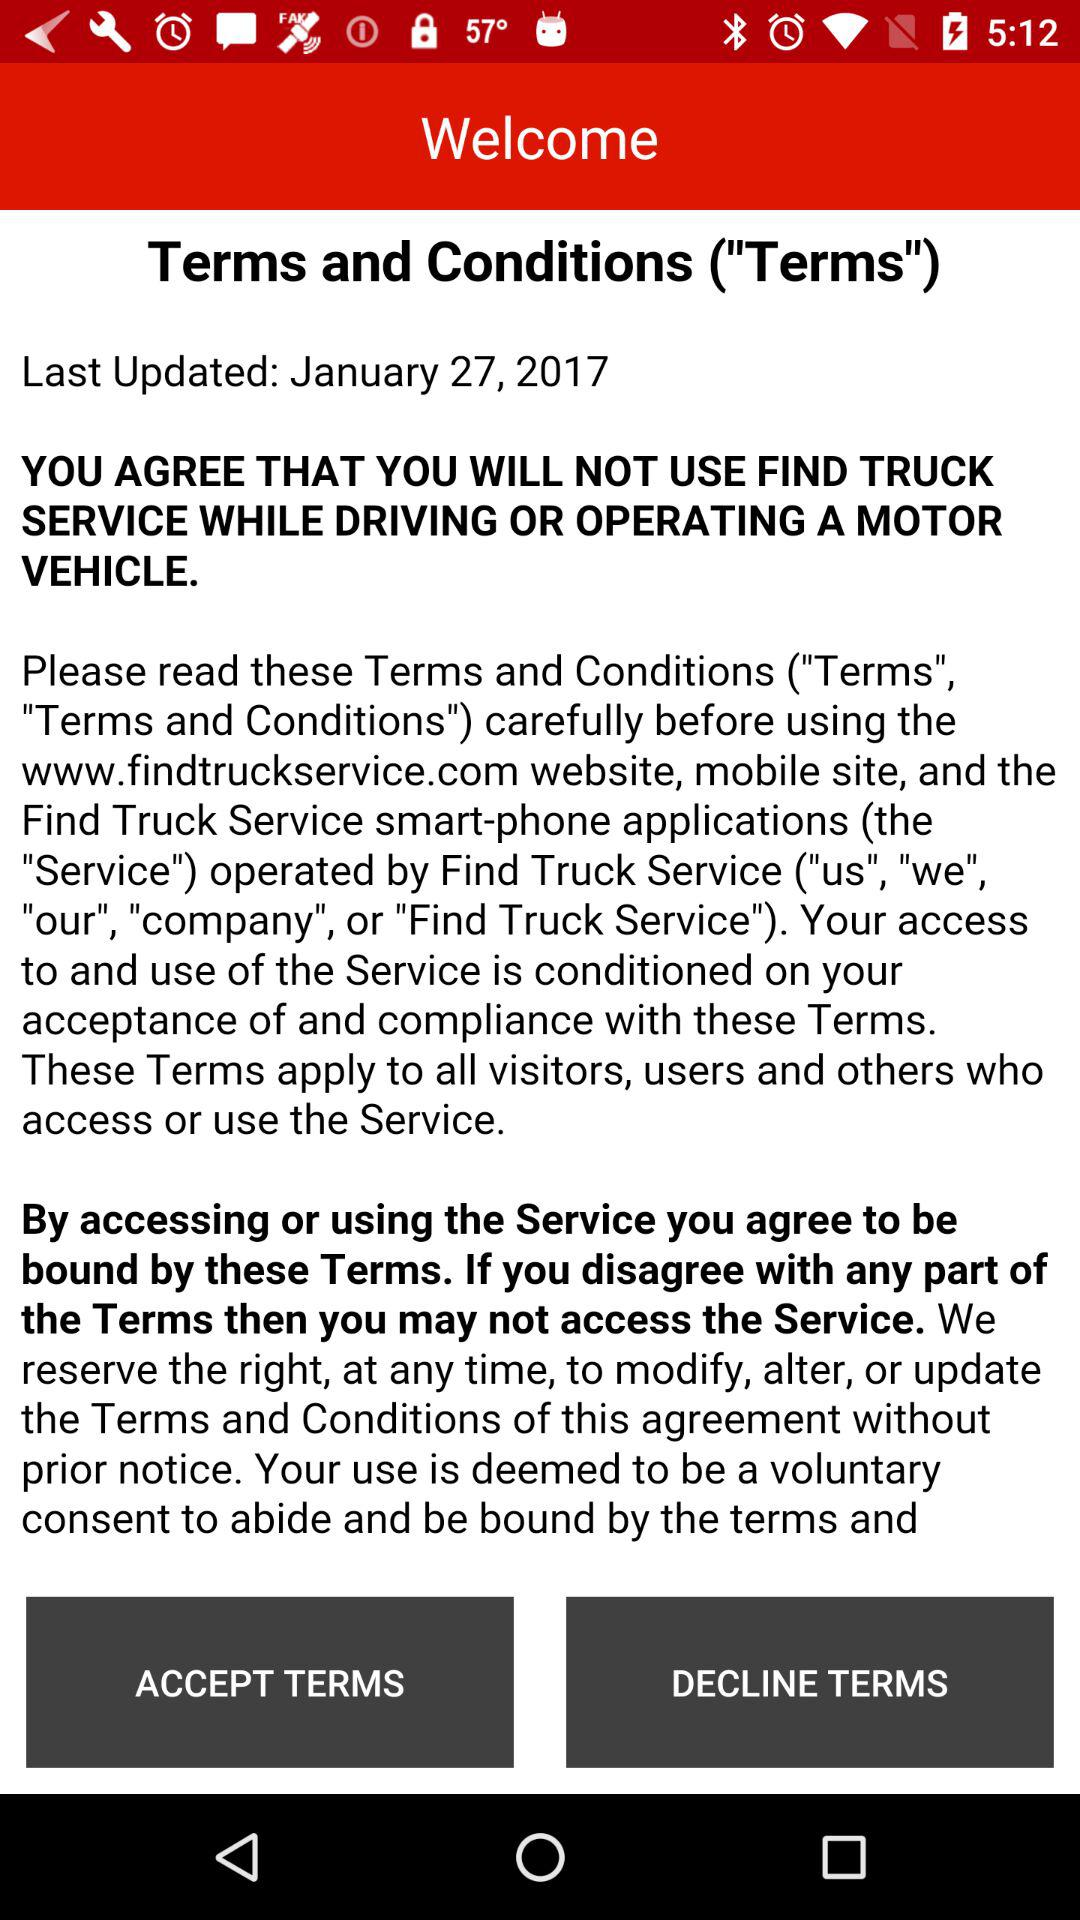When were the terms and conditions last updated? It was last updated on January 27, 2017. 